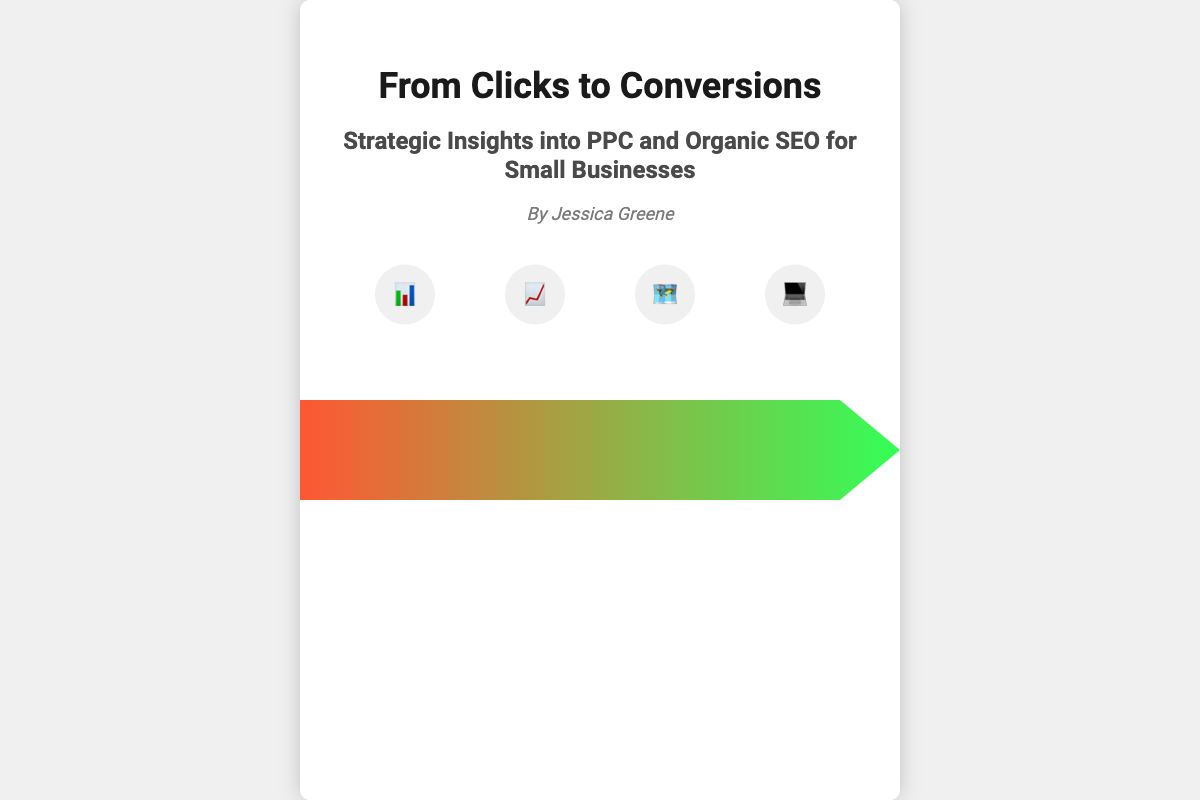What is the title of the book? The title of the book is prominently displayed in large font on the cover.
Answer: From Clicks to Conversions Who is the author? The author's name is listed below the title and subtitle on the cover.
Answer: Jessica Greene What is the main focus of the book? The subtitle provides insight into the primary topics discussed in the book.
Answer: PPC and Organic SEO What color is the arrow on the cover? The arrow, which transitions from left to right, is composed of a gradient of colors.
Answer: Red to Green How many icons are displayed at the bottom of the cover? The cover shows a set of circular icons representing various marketing elements.
Answer: Four What is the size of the book cover? The dimensions of the book cover provide a specific standard for its appearance.
Answer: 600 by 800 pixels What are the dominant themes depicted in the icons? The icons symbolize different key elements in digital marketing.
Answer: Digital Marketing Elements What design element represents the transition from PPC to Organic? The arrow visually connects the two sections of the cover to indicate the theme.
Answer: Arrow In what design style is the book cover created? The overall appearance of the cover reflects a blend of modern and professional aesthetics.
Answer: Modern Professional 